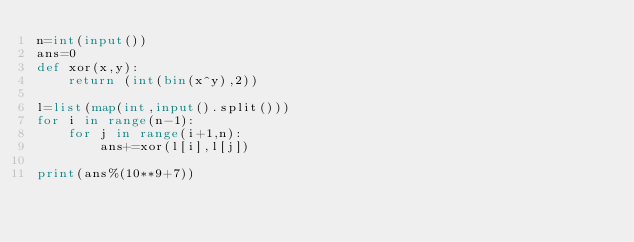Convert code to text. <code><loc_0><loc_0><loc_500><loc_500><_Python_>n=int(input())
ans=0
def xor(x,y):
    return (int(bin(x^y),2))
    
l=list(map(int,input().split()))
for i in range(n-1):
    for j in range(i+1,n):
        ans+=xor(l[i],l[j])
        
print(ans%(10**9+7))</code> 